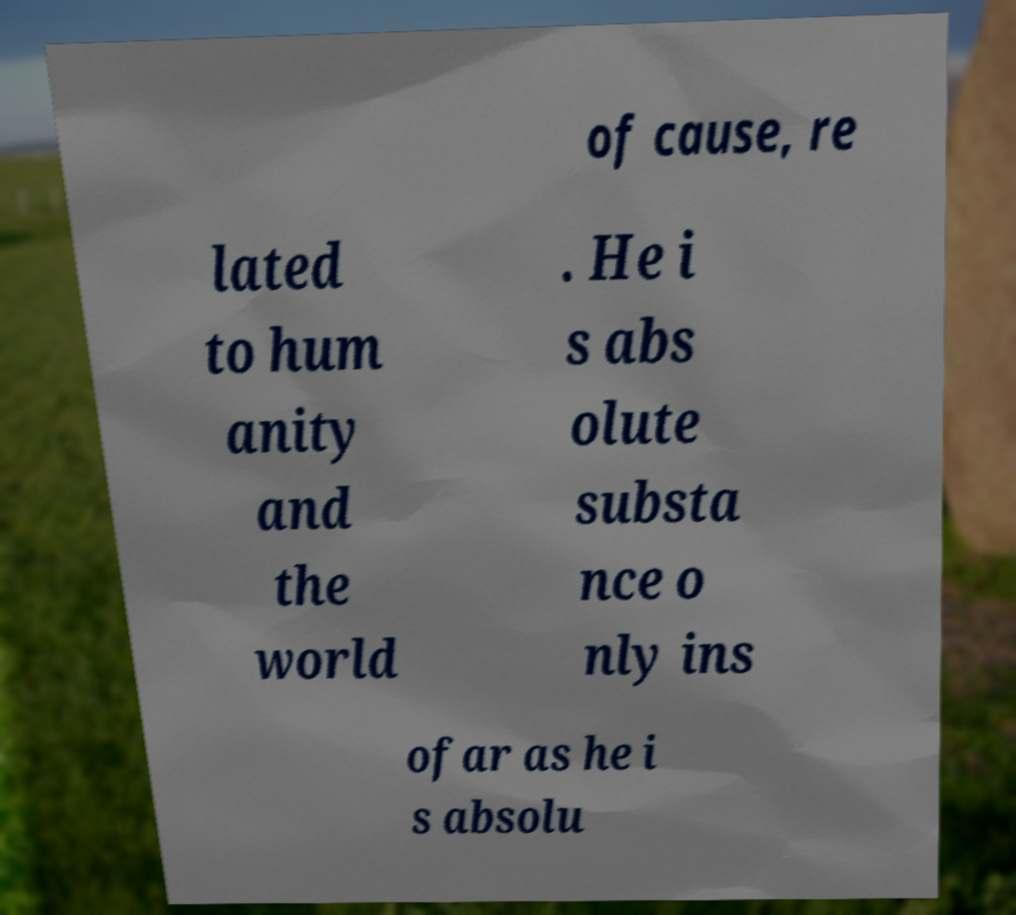Please read and relay the text visible in this image. What does it say? of cause, re lated to hum anity and the world . He i s abs olute substa nce o nly ins ofar as he i s absolu 